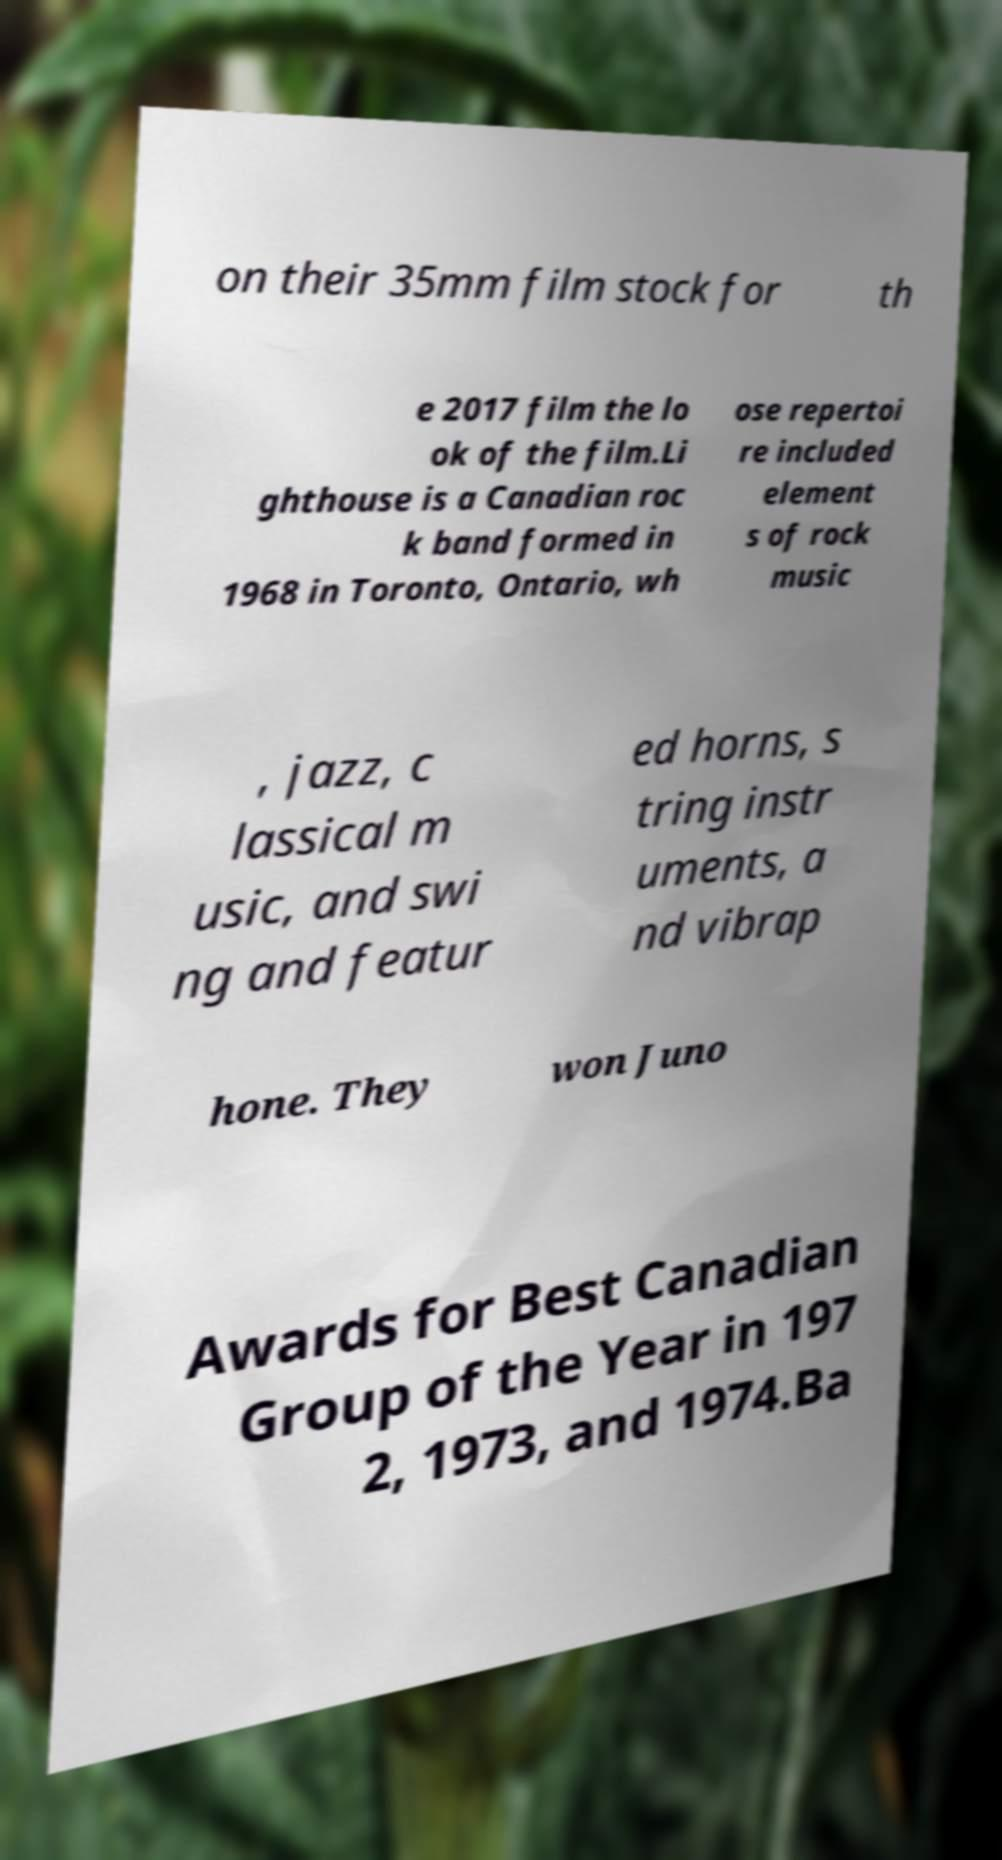Could you assist in decoding the text presented in this image and type it out clearly? on their 35mm film stock for th e 2017 film the lo ok of the film.Li ghthouse is a Canadian roc k band formed in 1968 in Toronto, Ontario, wh ose repertoi re included element s of rock music , jazz, c lassical m usic, and swi ng and featur ed horns, s tring instr uments, a nd vibrap hone. They won Juno Awards for Best Canadian Group of the Year in 197 2, 1973, and 1974.Ba 